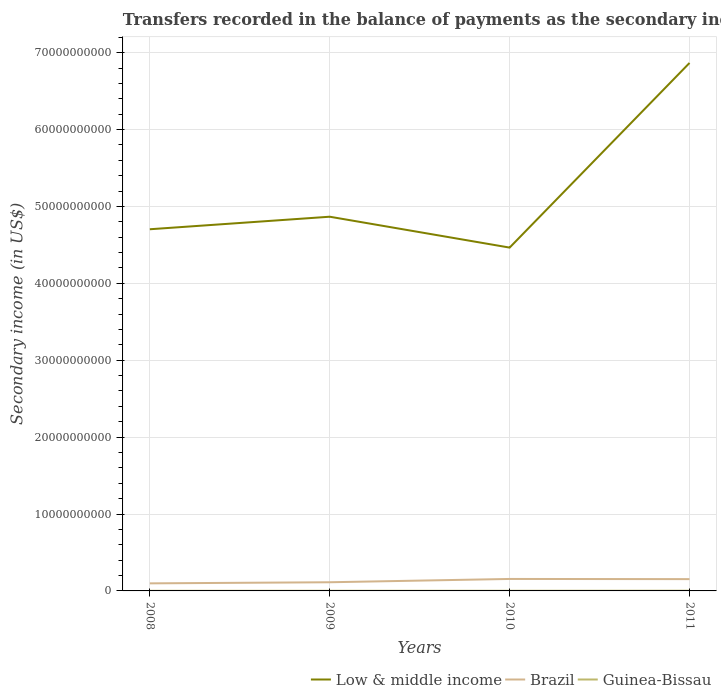Does the line corresponding to Brazil intersect with the line corresponding to Guinea-Bissau?
Provide a short and direct response. No. Is the number of lines equal to the number of legend labels?
Your answer should be compact. Yes. Across all years, what is the maximum secondary income of in Low & middle income?
Your response must be concise. 4.46e+1. In which year was the secondary income of in Low & middle income maximum?
Your answer should be very brief. 2010. What is the total secondary income of in Guinea-Bissau in the graph?
Provide a short and direct response. -1.23e+07. What is the difference between the highest and the second highest secondary income of in Low & middle income?
Your answer should be compact. 2.40e+1. What is the difference between the highest and the lowest secondary income of in Low & middle income?
Your answer should be compact. 1. How many lines are there?
Your answer should be compact. 3. What is the difference between two consecutive major ticks on the Y-axis?
Your response must be concise. 1.00e+1. Are the values on the major ticks of Y-axis written in scientific E-notation?
Provide a short and direct response. No. Does the graph contain grids?
Your response must be concise. Yes. What is the title of the graph?
Give a very brief answer. Transfers recorded in the balance of payments as the secondary income of a country. What is the label or title of the X-axis?
Your answer should be compact. Years. What is the label or title of the Y-axis?
Keep it short and to the point. Secondary income (in US$). What is the Secondary income (in US$) in Low & middle income in 2008?
Your response must be concise. 4.70e+1. What is the Secondary income (in US$) in Brazil in 2008?
Your response must be concise. 9.83e+08. What is the Secondary income (in US$) in Guinea-Bissau in 2008?
Offer a very short reply. 1.65e+07. What is the Secondary income (in US$) in Low & middle income in 2009?
Offer a terse response. 4.87e+1. What is the Secondary income (in US$) in Brazil in 2009?
Your answer should be very brief. 1.13e+09. What is the Secondary income (in US$) of Guinea-Bissau in 2009?
Offer a very short reply. 2.03e+07. What is the Secondary income (in US$) in Low & middle income in 2010?
Your answer should be very brief. 4.46e+1. What is the Secondary income (in US$) of Brazil in 2010?
Make the answer very short. 1.56e+09. What is the Secondary income (in US$) of Guinea-Bissau in 2010?
Your answer should be very brief. 1.95e+07. What is the Secondary income (in US$) of Low & middle income in 2011?
Keep it short and to the point. 6.87e+1. What is the Secondary income (in US$) in Brazil in 2011?
Your answer should be compact. 1.53e+09. What is the Secondary income (in US$) in Guinea-Bissau in 2011?
Offer a very short reply. 2.87e+07. Across all years, what is the maximum Secondary income (in US$) in Low & middle income?
Ensure brevity in your answer.  6.87e+1. Across all years, what is the maximum Secondary income (in US$) in Brazil?
Give a very brief answer. 1.56e+09. Across all years, what is the maximum Secondary income (in US$) of Guinea-Bissau?
Keep it short and to the point. 2.87e+07. Across all years, what is the minimum Secondary income (in US$) in Low & middle income?
Ensure brevity in your answer.  4.46e+1. Across all years, what is the minimum Secondary income (in US$) in Brazil?
Offer a terse response. 9.83e+08. Across all years, what is the minimum Secondary income (in US$) of Guinea-Bissau?
Offer a terse response. 1.65e+07. What is the total Secondary income (in US$) of Low & middle income in the graph?
Your answer should be very brief. 2.09e+11. What is the total Secondary income (in US$) of Brazil in the graph?
Your answer should be compact. 5.20e+09. What is the total Secondary income (in US$) of Guinea-Bissau in the graph?
Your answer should be compact. 8.50e+07. What is the difference between the Secondary income (in US$) in Low & middle income in 2008 and that in 2009?
Your response must be concise. -1.63e+09. What is the difference between the Secondary income (in US$) of Brazil in 2008 and that in 2009?
Provide a short and direct response. -1.44e+08. What is the difference between the Secondary income (in US$) of Guinea-Bissau in 2008 and that in 2009?
Your response must be concise. -3.81e+06. What is the difference between the Secondary income (in US$) in Low & middle income in 2008 and that in 2010?
Ensure brevity in your answer.  2.38e+09. What is the difference between the Secondary income (in US$) of Brazil in 2008 and that in 2010?
Your response must be concise. -5.73e+08. What is the difference between the Secondary income (in US$) of Guinea-Bissau in 2008 and that in 2010?
Your response must be concise. -3.02e+06. What is the difference between the Secondary income (in US$) of Low & middle income in 2008 and that in 2011?
Give a very brief answer. -2.16e+1. What is the difference between the Secondary income (in US$) of Brazil in 2008 and that in 2011?
Provide a succinct answer. -5.51e+08. What is the difference between the Secondary income (in US$) in Guinea-Bissau in 2008 and that in 2011?
Provide a succinct answer. -1.23e+07. What is the difference between the Secondary income (in US$) of Low & middle income in 2009 and that in 2010?
Offer a very short reply. 4.01e+09. What is the difference between the Secondary income (in US$) of Brazil in 2009 and that in 2010?
Your answer should be very brief. -4.29e+08. What is the difference between the Secondary income (in US$) in Guinea-Bissau in 2009 and that in 2010?
Your response must be concise. 7.90e+05. What is the difference between the Secondary income (in US$) of Low & middle income in 2009 and that in 2011?
Give a very brief answer. -2.00e+1. What is the difference between the Secondary income (in US$) of Brazil in 2009 and that in 2011?
Offer a very short reply. -4.07e+08. What is the difference between the Secondary income (in US$) of Guinea-Bissau in 2009 and that in 2011?
Your answer should be compact. -8.45e+06. What is the difference between the Secondary income (in US$) in Low & middle income in 2010 and that in 2011?
Provide a succinct answer. -2.40e+1. What is the difference between the Secondary income (in US$) in Brazil in 2010 and that in 2011?
Make the answer very short. 2.19e+07. What is the difference between the Secondary income (in US$) of Guinea-Bissau in 2010 and that in 2011?
Your response must be concise. -9.24e+06. What is the difference between the Secondary income (in US$) of Low & middle income in 2008 and the Secondary income (in US$) of Brazil in 2009?
Make the answer very short. 4.59e+1. What is the difference between the Secondary income (in US$) in Low & middle income in 2008 and the Secondary income (in US$) in Guinea-Bissau in 2009?
Your answer should be very brief. 4.70e+1. What is the difference between the Secondary income (in US$) of Brazil in 2008 and the Secondary income (in US$) of Guinea-Bissau in 2009?
Your response must be concise. 9.63e+08. What is the difference between the Secondary income (in US$) in Low & middle income in 2008 and the Secondary income (in US$) in Brazil in 2010?
Provide a short and direct response. 4.55e+1. What is the difference between the Secondary income (in US$) of Low & middle income in 2008 and the Secondary income (in US$) of Guinea-Bissau in 2010?
Offer a very short reply. 4.70e+1. What is the difference between the Secondary income (in US$) of Brazil in 2008 and the Secondary income (in US$) of Guinea-Bissau in 2010?
Provide a short and direct response. 9.64e+08. What is the difference between the Secondary income (in US$) in Low & middle income in 2008 and the Secondary income (in US$) in Brazil in 2011?
Provide a succinct answer. 4.55e+1. What is the difference between the Secondary income (in US$) of Low & middle income in 2008 and the Secondary income (in US$) of Guinea-Bissau in 2011?
Ensure brevity in your answer.  4.70e+1. What is the difference between the Secondary income (in US$) of Brazil in 2008 and the Secondary income (in US$) of Guinea-Bissau in 2011?
Provide a succinct answer. 9.55e+08. What is the difference between the Secondary income (in US$) of Low & middle income in 2009 and the Secondary income (in US$) of Brazil in 2010?
Provide a succinct answer. 4.71e+1. What is the difference between the Secondary income (in US$) of Low & middle income in 2009 and the Secondary income (in US$) of Guinea-Bissau in 2010?
Keep it short and to the point. 4.86e+1. What is the difference between the Secondary income (in US$) of Brazil in 2009 and the Secondary income (in US$) of Guinea-Bissau in 2010?
Your answer should be compact. 1.11e+09. What is the difference between the Secondary income (in US$) in Low & middle income in 2009 and the Secondary income (in US$) in Brazil in 2011?
Offer a very short reply. 4.71e+1. What is the difference between the Secondary income (in US$) in Low & middle income in 2009 and the Secondary income (in US$) in Guinea-Bissau in 2011?
Give a very brief answer. 4.86e+1. What is the difference between the Secondary income (in US$) in Brazil in 2009 and the Secondary income (in US$) in Guinea-Bissau in 2011?
Ensure brevity in your answer.  1.10e+09. What is the difference between the Secondary income (in US$) of Low & middle income in 2010 and the Secondary income (in US$) of Brazil in 2011?
Your response must be concise. 4.31e+1. What is the difference between the Secondary income (in US$) in Low & middle income in 2010 and the Secondary income (in US$) in Guinea-Bissau in 2011?
Provide a succinct answer. 4.46e+1. What is the difference between the Secondary income (in US$) of Brazil in 2010 and the Secondary income (in US$) of Guinea-Bissau in 2011?
Provide a succinct answer. 1.53e+09. What is the average Secondary income (in US$) of Low & middle income per year?
Give a very brief answer. 5.22e+1. What is the average Secondary income (in US$) in Brazil per year?
Offer a very short reply. 1.30e+09. What is the average Secondary income (in US$) of Guinea-Bissau per year?
Offer a very short reply. 2.12e+07. In the year 2008, what is the difference between the Secondary income (in US$) in Low & middle income and Secondary income (in US$) in Brazil?
Your answer should be very brief. 4.60e+1. In the year 2008, what is the difference between the Secondary income (in US$) of Low & middle income and Secondary income (in US$) of Guinea-Bissau?
Your answer should be compact. 4.70e+1. In the year 2008, what is the difference between the Secondary income (in US$) in Brazil and Secondary income (in US$) in Guinea-Bissau?
Your answer should be compact. 9.67e+08. In the year 2009, what is the difference between the Secondary income (in US$) of Low & middle income and Secondary income (in US$) of Brazil?
Your response must be concise. 4.75e+1. In the year 2009, what is the difference between the Secondary income (in US$) in Low & middle income and Secondary income (in US$) in Guinea-Bissau?
Your response must be concise. 4.86e+1. In the year 2009, what is the difference between the Secondary income (in US$) of Brazil and Secondary income (in US$) of Guinea-Bissau?
Your response must be concise. 1.11e+09. In the year 2010, what is the difference between the Secondary income (in US$) in Low & middle income and Secondary income (in US$) in Brazil?
Ensure brevity in your answer.  4.31e+1. In the year 2010, what is the difference between the Secondary income (in US$) in Low & middle income and Secondary income (in US$) in Guinea-Bissau?
Your answer should be compact. 4.46e+1. In the year 2010, what is the difference between the Secondary income (in US$) in Brazil and Secondary income (in US$) in Guinea-Bissau?
Your answer should be compact. 1.54e+09. In the year 2011, what is the difference between the Secondary income (in US$) of Low & middle income and Secondary income (in US$) of Brazil?
Your answer should be very brief. 6.71e+1. In the year 2011, what is the difference between the Secondary income (in US$) of Low & middle income and Secondary income (in US$) of Guinea-Bissau?
Your answer should be compact. 6.86e+1. In the year 2011, what is the difference between the Secondary income (in US$) of Brazil and Secondary income (in US$) of Guinea-Bissau?
Your answer should be very brief. 1.51e+09. What is the ratio of the Secondary income (in US$) of Low & middle income in 2008 to that in 2009?
Your answer should be compact. 0.97. What is the ratio of the Secondary income (in US$) in Brazil in 2008 to that in 2009?
Provide a succinct answer. 0.87. What is the ratio of the Secondary income (in US$) of Guinea-Bissau in 2008 to that in 2009?
Provide a short and direct response. 0.81. What is the ratio of the Secondary income (in US$) in Low & middle income in 2008 to that in 2010?
Offer a very short reply. 1.05. What is the ratio of the Secondary income (in US$) in Brazil in 2008 to that in 2010?
Offer a terse response. 0.63. What is the ratio of the Secondary income (in US$) in Guinea-Bissau in 2008 to that in 2010?
Your answer should be compact. 0.85. What is the ratio of the Secondary income (in US$) of Low & middle income in 2008 to that in 2011?
Your answer should be compact. 0.69. What is the ratio of the Secondary income (in US$) of Brazil in 2008 to that in 2011?
Give a very brief answer. 0.64. What is the ratio of the Secondary income (in US$) of Guinea-Bissau in 2008 to that in 2011?
Offer a terse response. 0.57. What is the ratio of the Secondary income (in US$) of Low & middle income in 2009 to that in 2010?
Offer a very short reply. 1.09. What is the ratio of the Secondary income (in US$) of Brazil in 2009 to that in 2010?
Keep it short and to the point. 0.72. What is the ratio of the Secondary income (in US$) in Guinea-Bissau in 2009 to that in 2010?
Give a very brief answer. 1.04. What is the ratio of the Secondary income (in US$) in Low & middle income in 2009 to that in 2011?
Give a very brief answer. 0.71. What is the ratio of the Secondary income (in US$) in Brazil in 2009 to that in 2011?
Offer a terse response. 0.73. What is the ratio of the Secondary income (in US$) in Guinea-Bissau in 2009 to that in 2011?
Offer a terse response. 0.71. What is the ratio of the Secondary income (in US$) of Low & middle income in 2010 to that in 2011?
Your response must be concise. 0.65. What is the ratio of the Secondary income (in US$) in Brazil in 2010 to that in 2011?
Offer a very short reply. 1.01. What is the ratio of the Secondary income (in US$) in Guinea-Bissau in 2010 to that in 2011?
Your answer should be compact. 0.68. What is the difference between the highest and the second highest Secondary income (in US$) of Low & middle income?
Offer a terse response. 2.00e+1. What is the difference between the highest and the second highest Secondary income (in US$) in Brazil?
Keep it short and to the point. 2.19e+07. What is the difference between the highest and the second highest Secondary income (in US$) of Guinea-Bissau?
Give a very brief answer. 8.45e+06. What is the difference between the highest and the lowest Secondary income (in US$) in Low & middle income?
Offer a very short reply. 2.40e+1. What is the difference between the highest and the lowest Secondary income (in US$) of Brazil?
Give a very brief answer. 5.73e+08. What is the difference between the highest and the lowest Secondary income (in US$) in Guinea-Bissau?
Make the answer very short. 1.23e+07. 